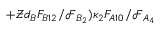Convert formula to latex. <formula><loc_0><loc_0><loc_500><loc_500>+ \mathcal { Z } d _ { B } F _ { B 1 2 } / \mathcal { F } _ { B _ { 2 } } ) \kappa _ { 2 } F _ { A 1 0 } / \mathcal { F } _ { A _ { 4 } }</formula> 